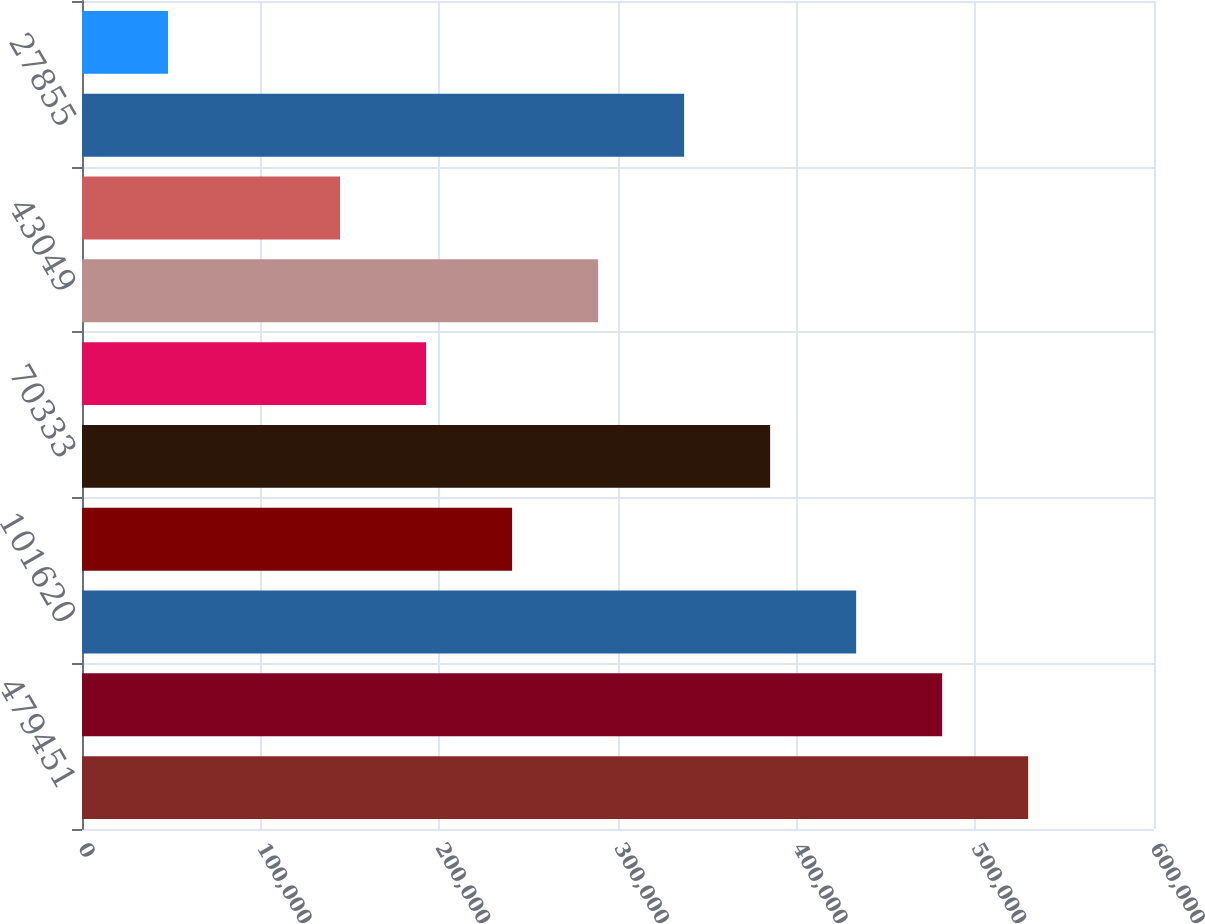<chart> <loc_0><loc_0><loc_500><loc_500><bar_chart><fcel>479451<fcel>377831<fcel>101620<fcel>31287<fcel>70333<fcel>27284<fcel>43049<fcel>(15194)<fcel>27855<fcel>070<nl><fcel>529574<fcel>481431<fcel>433288<fcel>240716<fcel>385145<fcel>192573<fcel>288859<fcel>144430<fcel>337002<fcel>48143.8<nl></chart> 